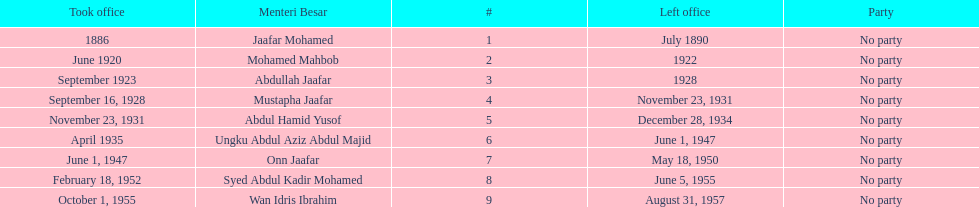How long did ungku abdul aziz abdul majid serve? 12 years. 